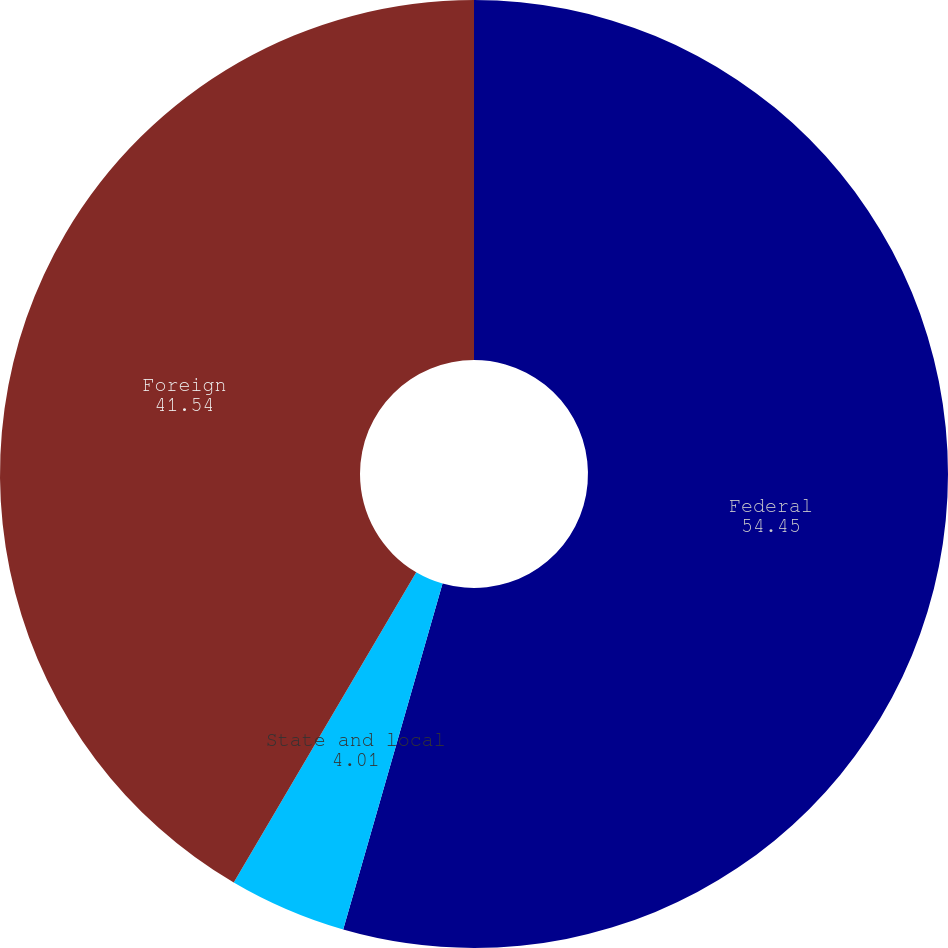Convert chart. <chart><loc_0><loc_0><loc_500><loc_500><pie_chart><fcel>Federal<fcel>State and local<fcel>Foreign<nl><fcel>54.45%<fcel>4.01%<fcel>41.54%<nl></chart> 